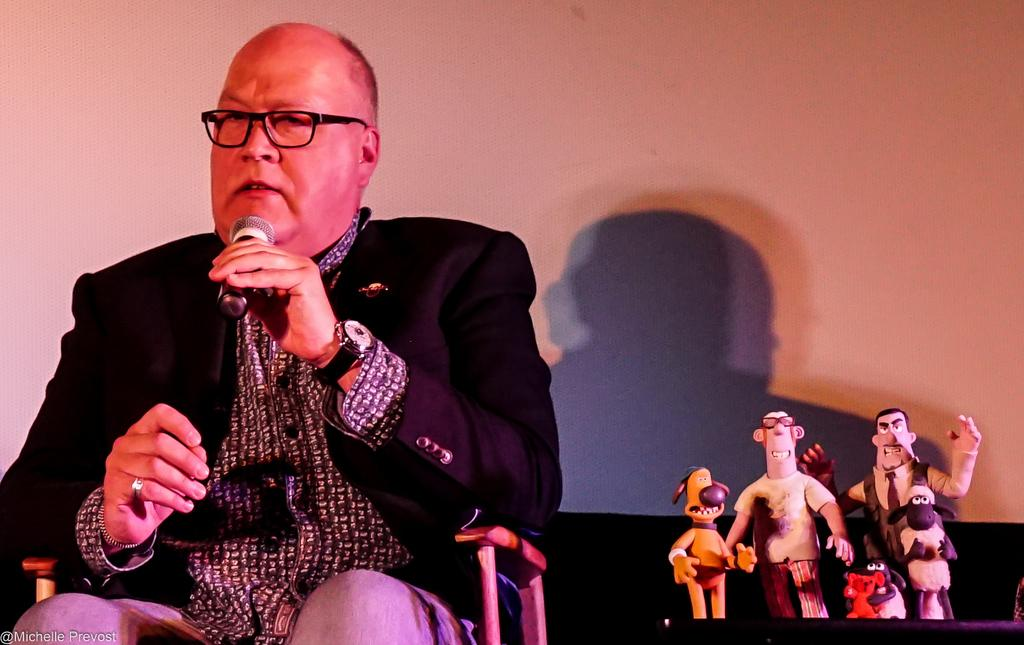Who is the main subject in the image? There is a man in the image. What is the man doing in the image? The man is sitting on a chair and holding a microphone in his hand. What else can be seen in the image besides the man? There is a table in the image, and Shaun the Sheep cartoon characters are present on the table. What type of balance does the scarecrow have in the image? There is no scarecrow present in the image. How does the man's dad feel about his son holding a microphone in the image? The provided facts do not mention the man's dad or his feelings, so we cannot answer this question. 